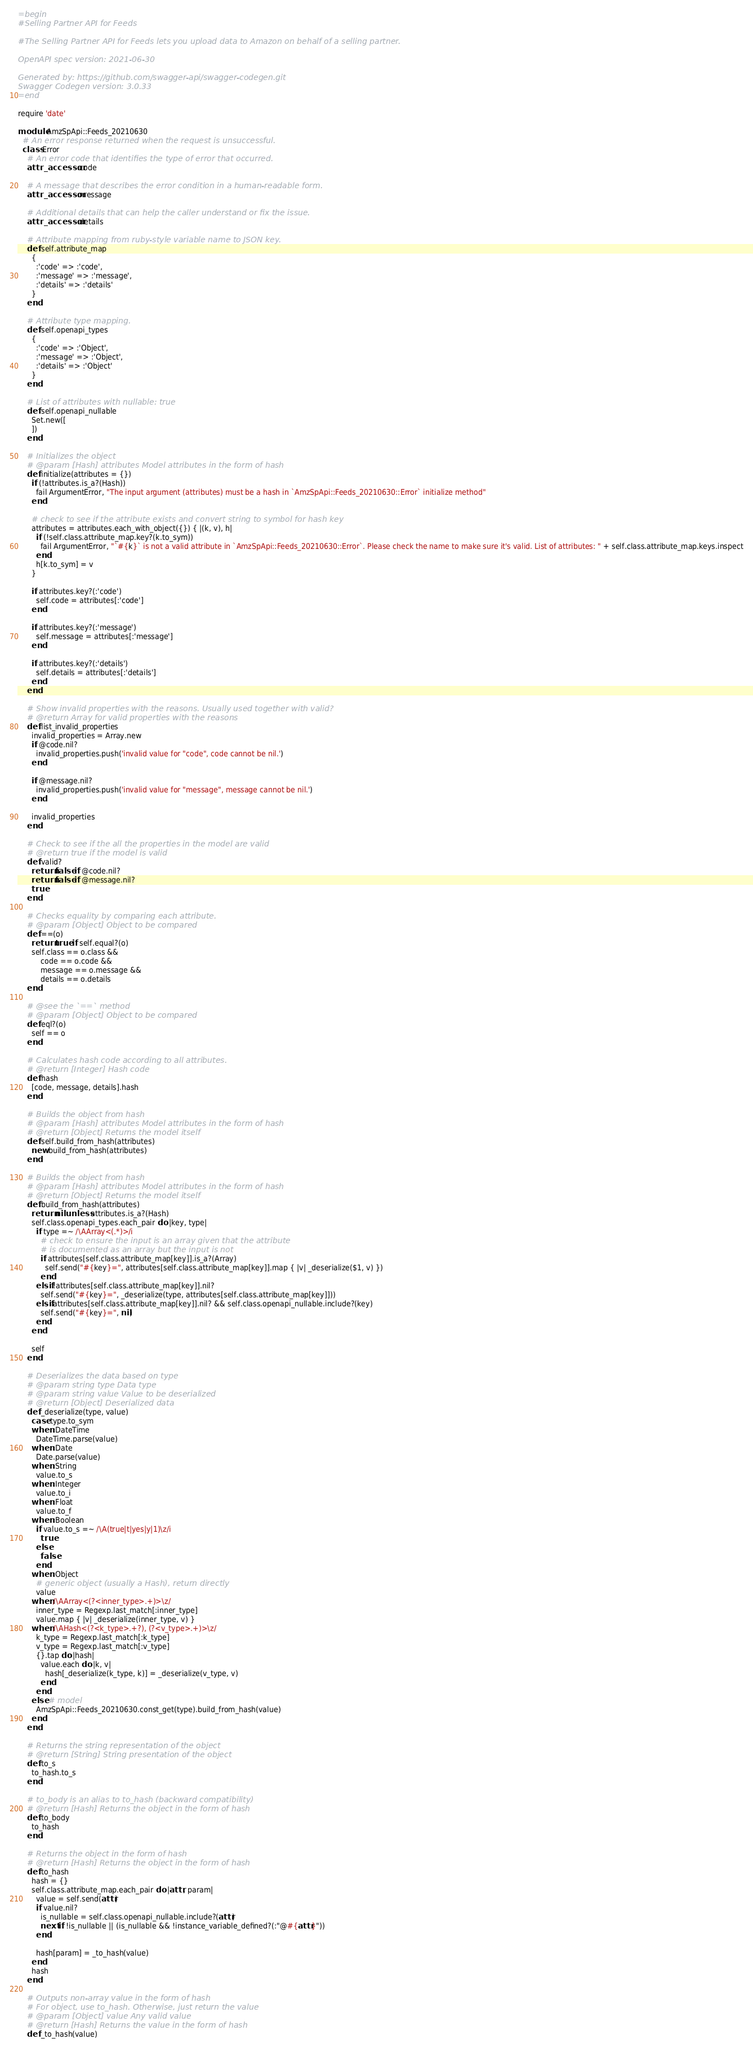Convert code to text. <code><loc_0><loc_0><loc_500><loc_500><_Ruby_>=begin
#Selling Partner API for Feeds

#The Selling Partner API for Feeds lets you upload data to Amazon on behalf of a selling partner.

OpenAPI spec version: 2021-06-30

Generated by: https://github.com/swagger-api/swagger-codegen.git
Swagger Codegen version: 3.0.33
=end

require 'date'

module AmzSpApi::Feeds_20210630
  # An error response returned when the request is unsuccessful.
  class Error
    # An error code that identifies the type of error that occurred.
    attr_accessor :code

    # A message that describes the error condition in a human-readable form.
    attr_accessor :message

    # Additional details that can help the caller understand or fix the issue.
    attr_accessor :details

    # Attribute mapping from ruby-style variable name to JSON key.
    def self.attribute_map
      {
        :'code' => :'code',
        :'message' => :'message',
        :'details' => :'details'
      }
    end

    # Attribute type mapping.
    def self.openapi_types
      {
        :'code' => :'Object',
        :'message' => :'Object',
        :'details' => :'Object'
      }
    end

    # List of attributes with nullable: true
    def self.openapi_nullable
      Set.new([
      ])
    end
  
    # Initializes the object
    # @param [Hash] attributes Model attributes in the form of hash
    def initialize(attributes = {})
      if (!attributes.is_a?(Hash))
        fail ArgumentError, "The input argument (attributes) must be a hash in `AmzSpApi::Feeds_20210630::Error` initialize method"
      end

      # check to see if the attribute exists and convert string to symbol for hash key
      attributes = attributes.each_with_object({}) { |(k, v), h|
        if (!self.class.attribute_map.key?(k.to_sym))
          fail ArgumentError, "`#{k}` is not a valid attribute in `AmzSpApi::Feeds_20210630::Error`. Please check the name to make sure it's valid. List of attributes: " + self.class.attribute_map.keys.inspect
        end
        h[k.to_sym] = v
      }

      if attributes.key?(:'code')
        self.code = attributes[:'code']
      end

      if attributes.key?(:'message')
        self.message = attributes[:'message']
      end

      if attributes.key?(:'details')
        self.details = attributes[:'details']
      end
    end

    # Show invalid properties with the reasons. Usually used together with valid?
    # @return Array for valid properties with the reasons
    def list_invalid_properties
      invalid_properties = Array.new
      if @code.nil?
        invalid_properties.push('invalid value for "code", code cannot be nil.')
      end

      if @message.nil?
        invalid_properties.push('invalid value for "message", message cannot be nil.')
      end

      invalid_properties
    end

    # Check to see if the all the properties in the model are valid
    # @return true if the model is valid
    def valid?
      return false if @code.nil?
      return false if @message.nil?
      true
    end

    # Checks equality by comparing each attribute.
    # @param [Object] Object to be compared
    def ==(o)
      return true if self.equal?(o)
      self.class == o.class &&
          code == o.code &&
          message == o.message &&
          details == o.details
    end

    # @see the `==` method
    # @param [Object] Object to be compared
    def eql?(o)
      self == o
    end

    # Calculates hash code according to all attributes.
    # @return [Integer] Hash code
    def hash
      [code, message, details].hash
    end

    # Builds the object from hash
    # @param [Hash] attributes Model attributes in the form of hash
    # @return [Object] Returns the model itself
    def self.build_from_hash(attributes)
      new.build_from_hash(attributes)
    end

    # Builds the object from hash
    # @param [Hash] attributes Model attributes in the form of hash
    # @return [Object] Returns the model itself
    def build_from_hash(attributes)
      return nil unless attributes.is_a?(Hash)
      self.class.openapi_types.each_pair do |key, type|
        if type =~ /\AArray<(.*)>/i
          # check to ensure the input is an array given that the attribute
          # is documented as an array but the input is not
          if attributes[self.class.attribute_map[key]].is_a?(Array)
            self.send("#{key}=", attributes[self.class.attribute_map[key]].map { |v| _deserialize($1, v) })
          end
        elsif !attributes[self.class.attribute_map[key]].nil?
          self.send("#{key}=", _deserialize(type, attributes[self.class.attribute_map[key]]))
        elsif attributes[self.class.attribute_map[key]].nil? && self.class.openapi_nullable.include?(key)
          self.send("#{key}=", nil)
        end
      end

      self
    end

    # Deserializes the data based on type
    # @param string type Data type
    # @param string value Value to be deserialized
    # @return [Object] Deserialized data
    def _deserialize(type, value)
      case type.to_sym
      when :DateTime
        DateTime.parse(value)
      when :Date
        Date.parse(value)
      when :String
        value.to_s
      when :Integer
        value.to_i
      when :Float
        value.to_f
      when :Boolean
        if value.to_s =~ /\A(true|t|yes|y|1)\z/i
          true
        else
          false
        end
      when :Object
        # generic object (usually a Hash), return directly
        value
      when /\AArray<(?<inner_type>.+)>\z/
        inner_type = Regexp.last_match[:inner_type]
        value.map { |v| _deserialize(inner_type, v) }
      when /\AHash<(?<k_type>.+?), (?<v_type>.+)>\z/
        k_type = Regexp.last_match[:k_type]
        v_type = Regexp.last_match[:v_type]
        {}.tap do |hash|
          value.each do |k, v|
            hash[_deserialize(k_type, k)] = _deserialize(v_type, v)
          end
        end
      else # model
        AmzSpApi::Feeds_20210630.const_get(type).build_from_hash(value)
      end
    end

    # Returns the string representation of the object
    # @return [String] String presentation of the object
    def to_s
      to_hash.to_s
    end

    # to_body is an alias to to_hash (backward compatibility)
    # @return [Hash] Returns the object in the form of hash
    def to_body
      to_hash
    end

    # Returns the object in the form of hash
    # @return [Hash] Returns the object in the form of hash
    def to_hash
      hash = {}
      self.class.attribute_map.each_pair do |attr, param|
        value = self.send(attr)
        if value.nil?
          is_nullable = self.class.openapi_nullable.include?(attr)
          next if !is_nullable || (is_nullable && !instance_variable_defined?(:"@#{attr}"))
        end

        hash[param] = _to_hash(value)
      end
      hash
    end

    # Outputs non-array value in the form of hash
    # For object, use to_hash. Otherwise, just return the value
    # @param [Object] value Any valid value
    # @return [Hash] Returns the value in the form of hash
    def _to_hash(value)</code> 